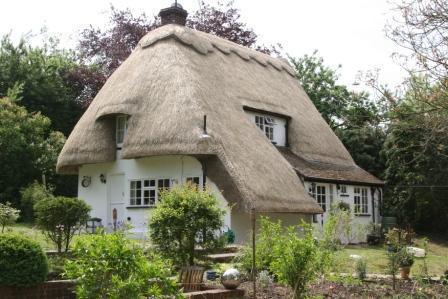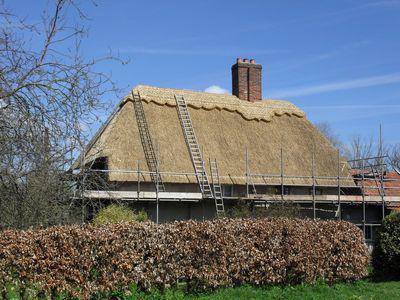The first image is the image on the left, the second image is the image on the right. Evaluate the accuracy of this statement regarding the images: "Men are repairing a roof.". Is it true? Answer yes or no. No. The first image is the image on the left, the second image is the image on the right. Evaluate the accuracy of this statement regarding the images: "At least one man is standing on a ladder propped against an unfinished thatched roof.". Is it true? Answer yes or no. No. 